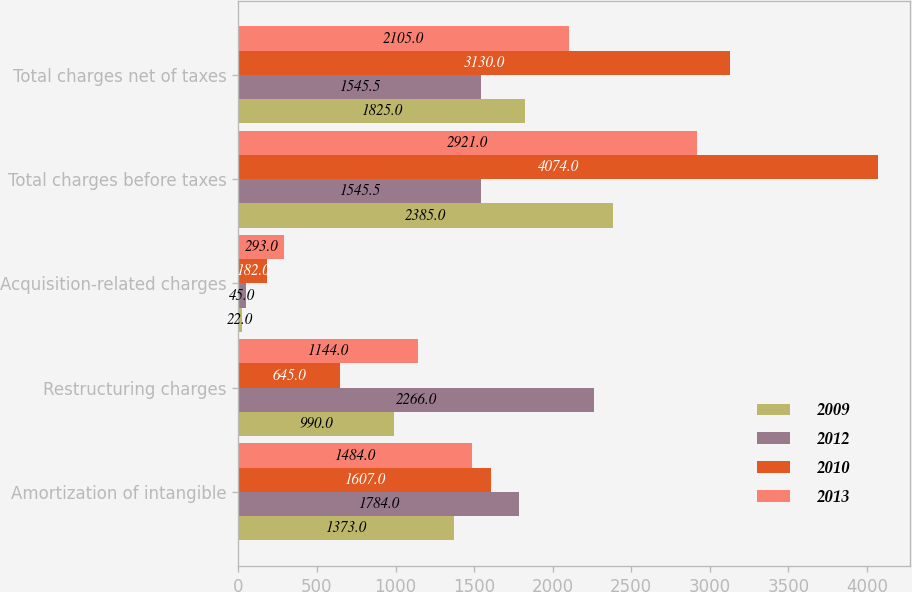Convert chart. <chart><loc_0><loc_0><loc_500><loc_500><stacked_bar_chart><ecel><fcel>Amortization of intangible<fcel>Restructuring charges<fcel>Acquisition-related charges<fcel>Total charges before taxes<fcel>Total charges net of taxes<nl><fcel>2009<fcel>1373<fcel>990<fcel>22<fcel>2385<fcel>1825<nl><fcel>2012<fcel>1784<fcel>2266<fcel>45<fcel>1545.5<fcel>1545.5<nl><fcel>2010<fcel>1607<fcel>645<fcel>182<fcel>4074<fcel>3130<nl><fcel>2013<fcel>1484<fcel>1144<fcel>293<fcel>2921<fcel>2105<nl></chart> 